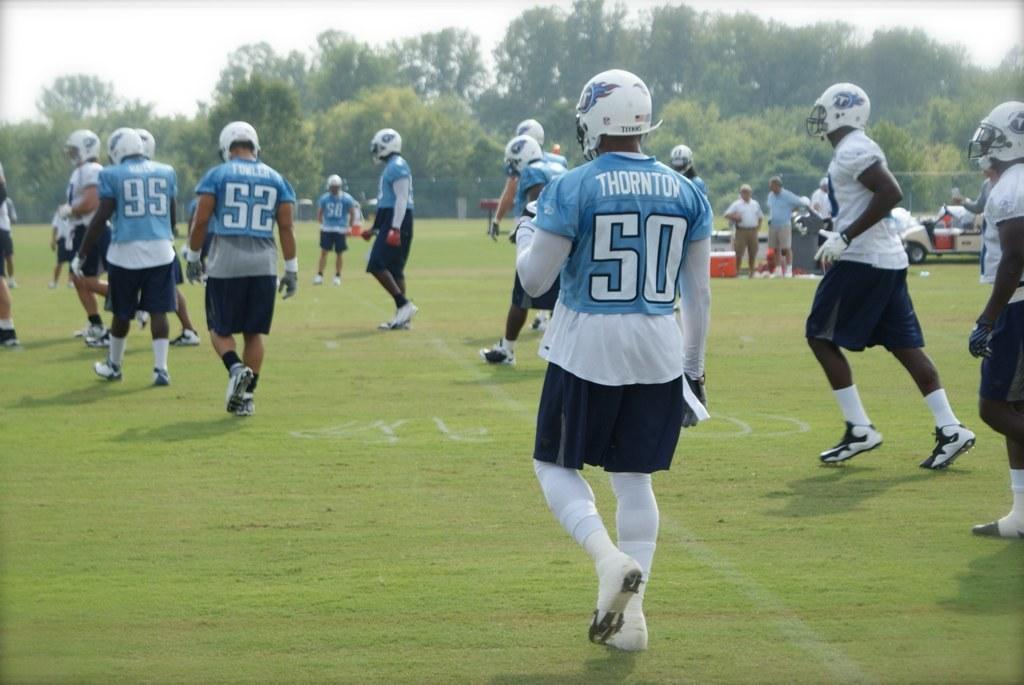How would you summarize this image in a sentence or two? In this image we can see few persons are walking on the ground. In the background we can see few persons are standing, objects, vehicle, trees and the sky. 